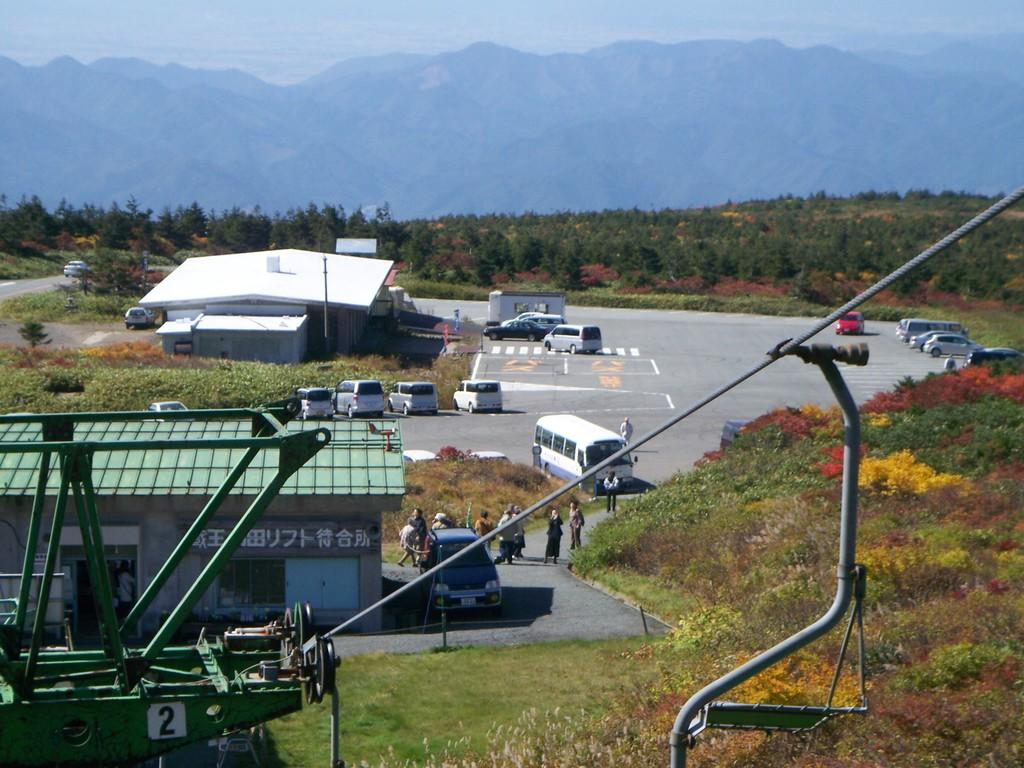What types of objects can be seen in the image? There are vehicles, sheds, plants, trees, and mountains in the image. What other items are present in the image? There is rope and poles in the image. What can be seen in the sky in the image? The sky is visible in the image. What type of wire is being used to generate profit in the image? There is no wire or mention of profit in the image; it features vehicles, sheds, plants, trees, mountains, rope, and poles. How many wings are visible on the vehicles in the image? There are no wings visible on the vehicles in the image; they are not depicted as flying or having wings. 